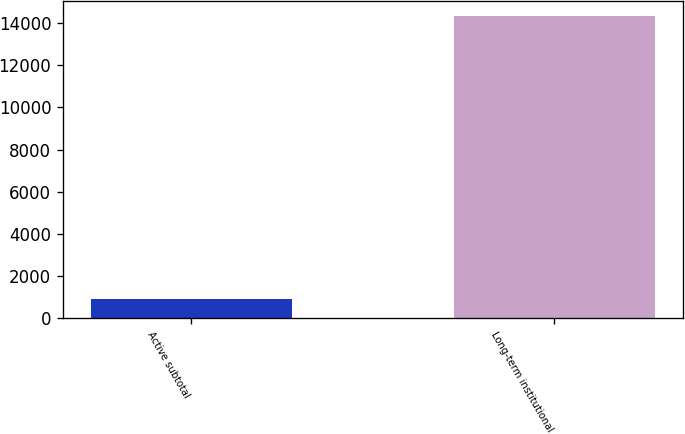Convert chart to OTSL. <chart><loc_0><loc_0><loc_500><loc_500><bar_chart><fcel>Active subtotal<fcel>Long-term institutional<nl><fcel>928<fcel>14338<nl></chart> 